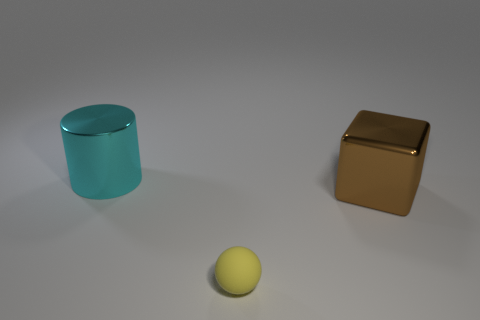What material is the large thing in front of the cyan cylinder?
Offer a terse response. Metal. Are the object in front of the large block and the large cyan cylinder made of the same material?
Your response must be concise. No. There is a thing that is the same size as the cube; what is its shape?
Ensure brevity in your answer.  Cylinder. What number of blocks have the same color as the small rubber object?
Offer a terse response. 0. Is the number of shiny things to the left of the big cyan cylinder less than the number of tiny yellow spheres that are left of the brown shiny cube?
Ensure brevity in your answer.  Yes. There is a sphere; are there any large shiny cubes behind it?
Make the answer very short. Yes. There is a large thing in front of the large shiny object that is left of the cube; are there any small yellow rubber spheres right of it?
Ensure brevity in your answer.  No. There is a large cube that is the same material as the big cylinder; what color is it?
Provide a short and direct response. Brown. What number of cylinders are made of the same material as the block?
Offer a very short reply. 1. There is a large metallic thing that is behind the large shiny thing that is right of the big thing that is behind the brown cube; what is its color?
Your answer should be very brief. Cyan. 